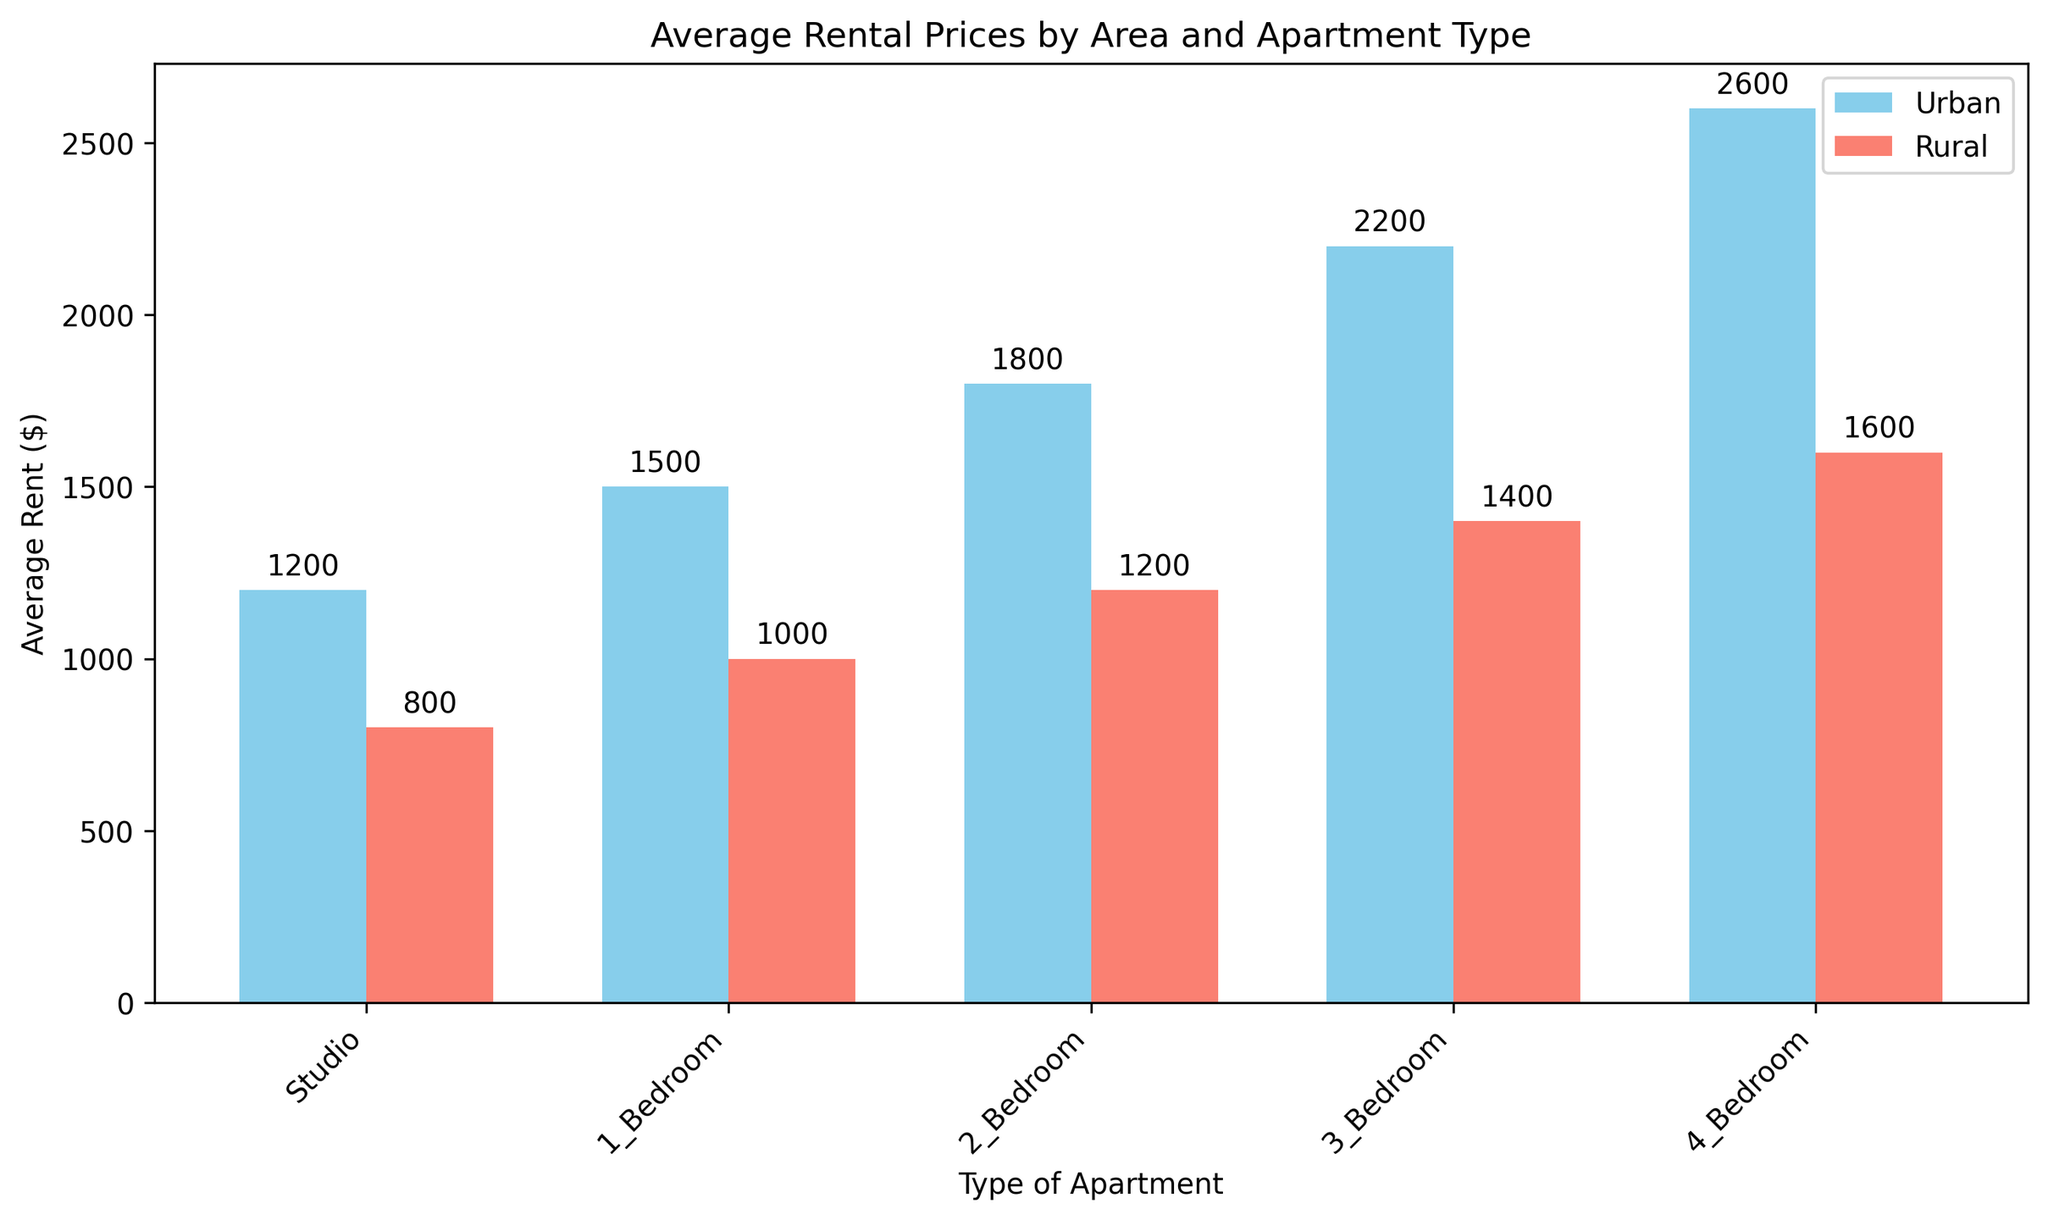What's the average rent for 3-Bedroom apartments in both urban and rural areas combined? The average rent for 3-Bedroom apartments is calculated by adding the rents in urban and rural areas and then dividing by 2: (2200 + 1400) / 2 = 3600 / 2 = 1800
Answer: 1800 Which area has a higher average rent for a Studio apartment, and by how much? Compare the average rent for Studio apartments: Urban ($1200) vs Rural ($800). The difference is 1200 - 800 = 400. Urban has a higher rent by 400.
Answer: Urban, 400 In which apartment type is the rent difference between urban and rural areas the largest? Calculate the differences for each type: Studio (1200 - 800 = 400), 1_Bedroom (1500 - 1000 = 500), 2_Bedroom (1800 - 1200 = 600), 3_Bedroom (2200 - 1400 = 800), 4_Bedroom (2600 - 1600 = 1000). The largest difference is in the 4_Bedroom type (1000).
Answer: 4_Bedroom What's the total rent amount for all apartment types in rural areas? Add the average rents for all types in rural areas: 800 + 1000 + 1200 + 1400 + 1600 = 6000
Answer: 6000 Which apartment type has the smallest rent difference between urban and rural areas? Calculate the differences for each type: Studio (1200 - 800 = 400), 1_Bedroom (1500 - 1000 = 500), 2_Bedroom (1800 - 1200 = 600), 3_Bedroom (2200 - 1400 = 800), 4_Bedroom (2600 - 1600 = 1000). The smallest difference is in the Studio type (400).
Answer: Studio What is the sum of the average rents for the 2-Bedroom and 3-Bedroom apartments in urban areas? Add the average rents for 2-Bedroom and 3-Bedroom apartments in urban areas: 1800 + 2200 = 4000
Answer: 4000 